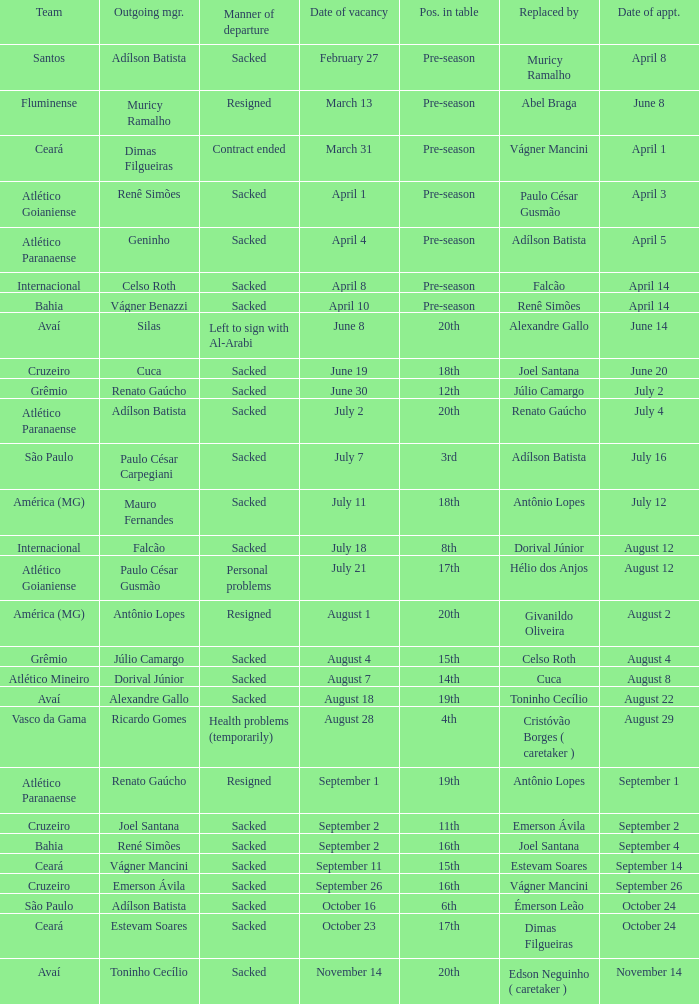How many times did Silas leave as a team manager? 1.0. 